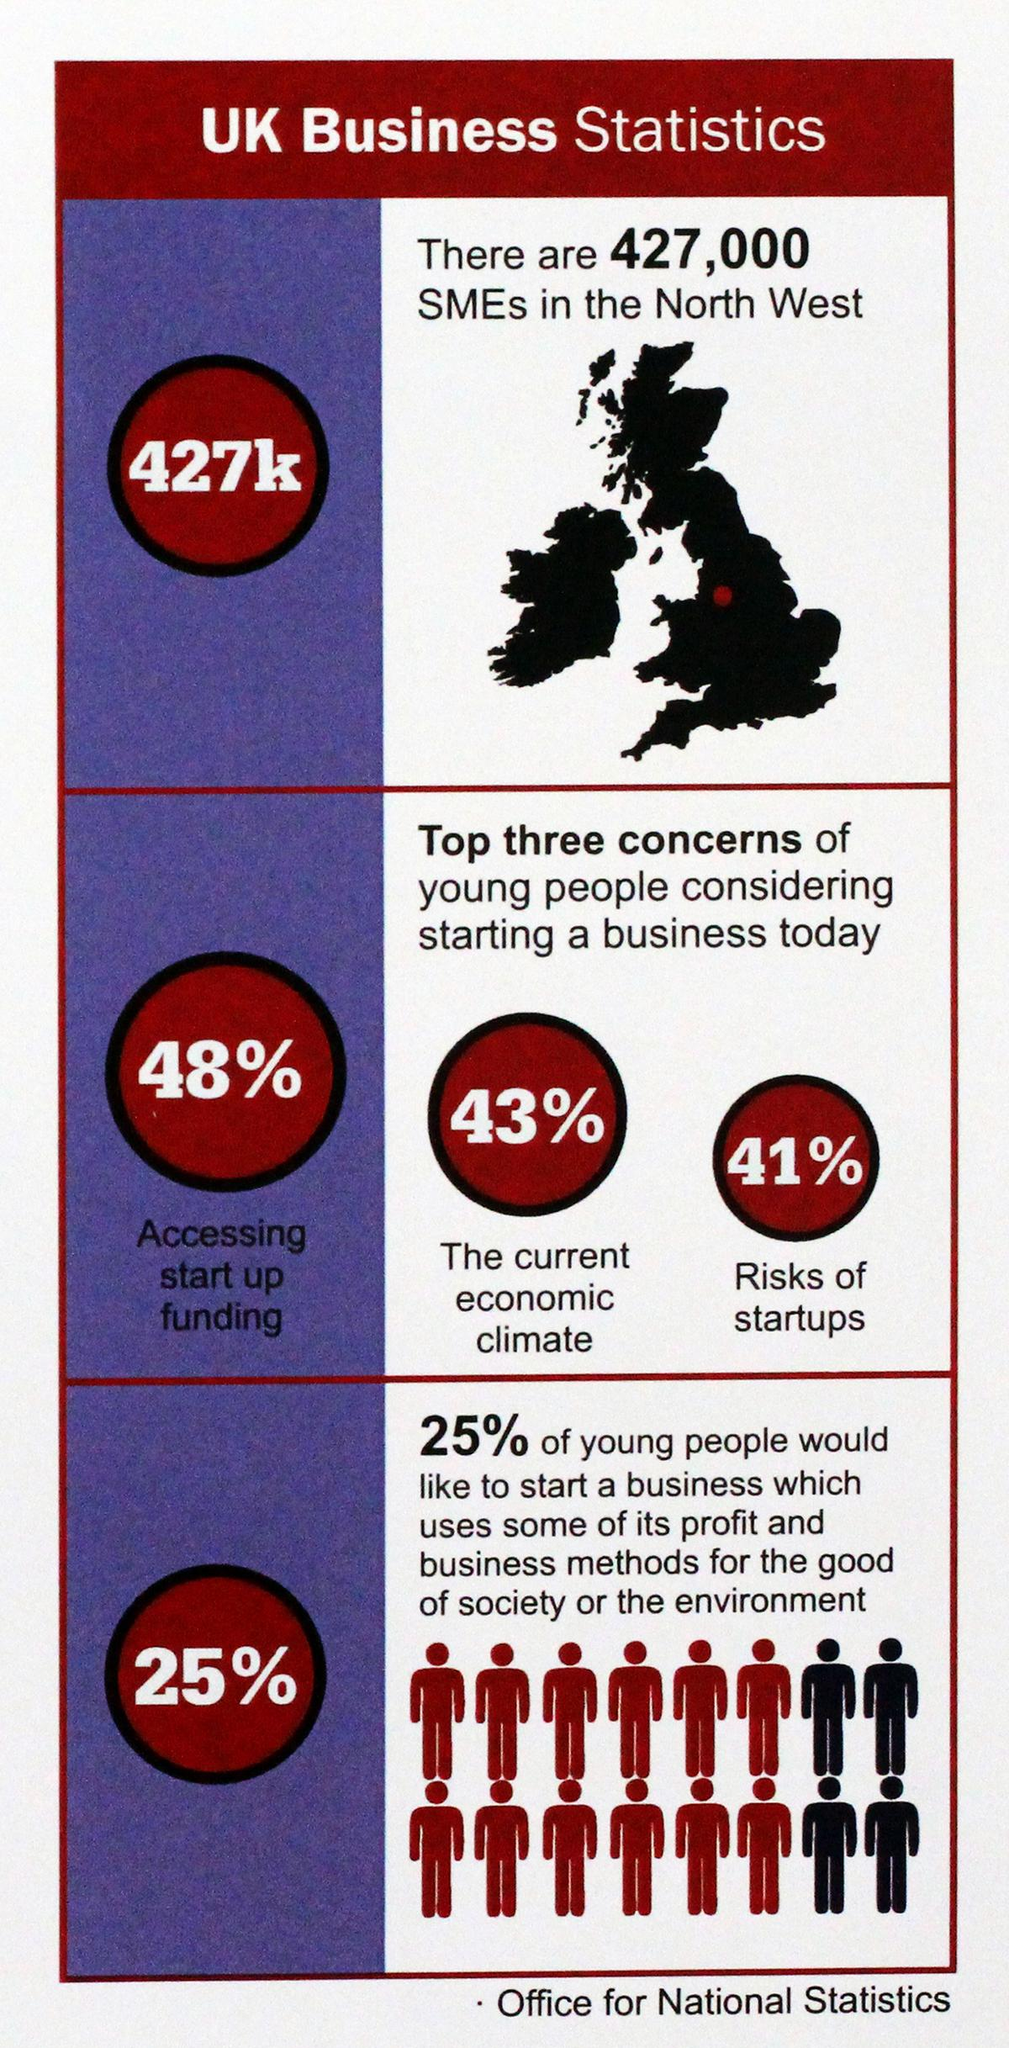Draw attention to some important aspects in this diagram. In addition to funding and economic conditions, young people are most concerned about the risks associated with startups. Young people are primarily concerned about accessing startup funding when considering a potential startup. Young people are primarily concerned about startups, in addition to funding, in the current economic climate. 